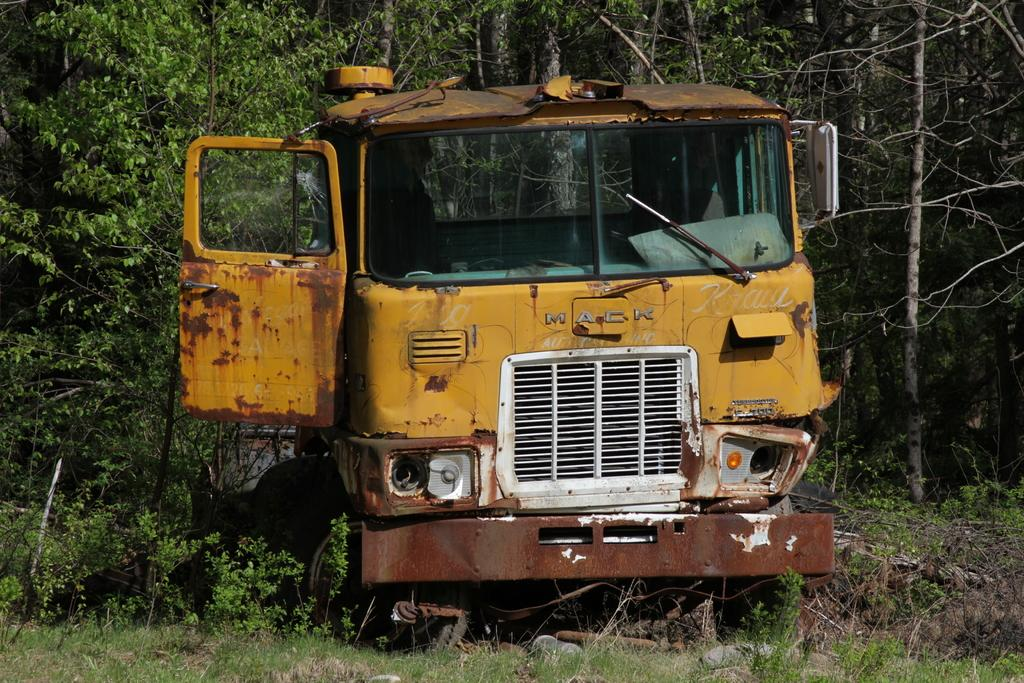What is the main subject of the image? The main subject of the image is a broken vehicle. Where is the broken vehicle located in the image? The broken vehicle is in the middle of the image. What can be seen in the background of the image? There are trees in the background of the image. What statement is being made by the table in the image? There is no table present in the image, so no statement can be attributed to it. 